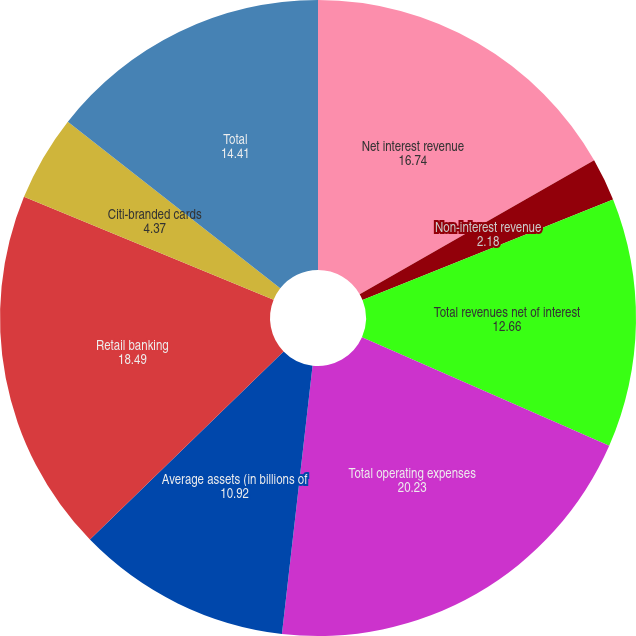<chart> <loc_0><loc_0><loc_500><loc_500><pie_chart><fcel>Net interest revenue<fcel>Non-interest revenue<fcel>Total revenues net of interest<fcel>Total operating expenses<fcel>Average assets (in billions of<fcel>Retail banking<fcel>Citi-branded cards<fcel>Total<nl><fcel>16.74%<fcel>2.18%<fcel>12.66%<fcel>20.23%<fcel>10.92%<fcel>18.49%<fcel>4.37%<fcel>14.41%<nl></chart> 